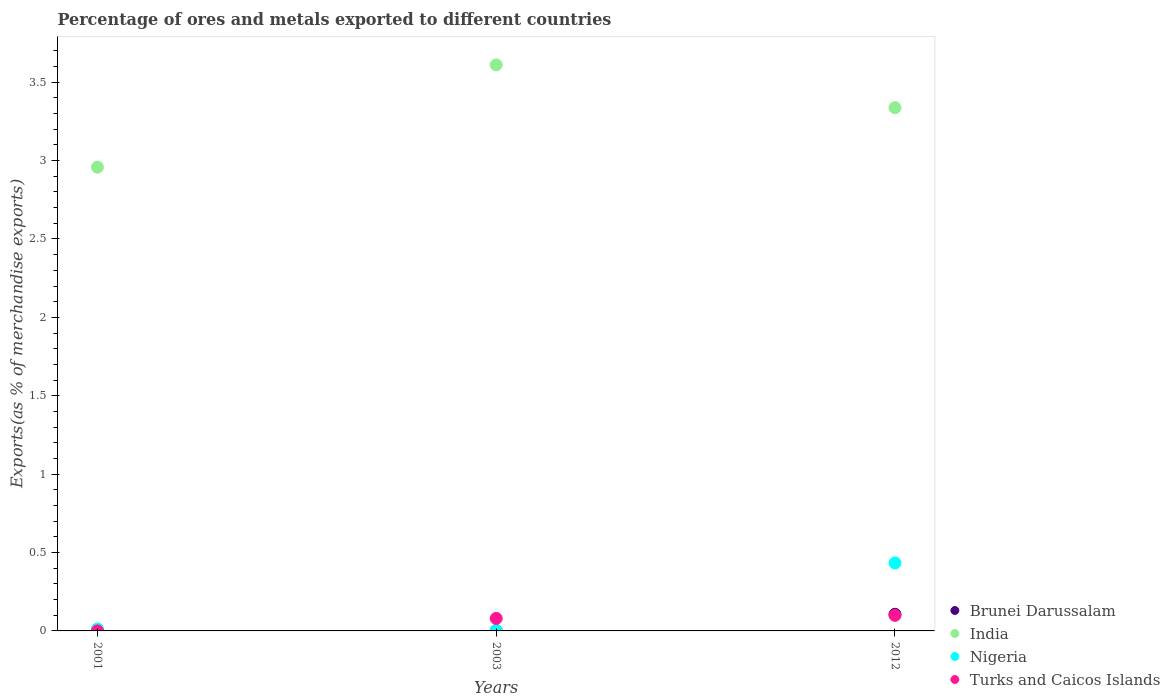How many different coloured dotlines are there?
Provide a succinct answer. 4. Is the number of dotlines equal to the number of legend labels?
Provide a short and direct response. Yes. What is the percentage of exports to different countries in Turks and Caicos Islands in 2003?
Ensure brevity in your answer.  0.08. Across all years, what is the maximum percentage of exports to different countries in Brunei Darussalam?
Make the answer very short. 0.11. Across all years, what is the minimum percentage of exports to different countries in India?
Provide a short and direct response. 2.96. In which year was the percentage of exports to different countries in India maximum?
Keep it short and to the point. 2003. In which year was the percentage of exports to different countries in India minimum?
Keep it short and to the point. 2001. What is the total percentage of exports to different countries in India in the graph?
Offer a terse response. 9.91. What is the difference between the percentage of exports to different countries in India in 2003 and that in 2012?
Give a very brief answer. 0.27. What is the difference between the percentage of exports to different countries in Turks and Caicos Islands in 2003 and the percentage of exports to different countries in Nigeria in 2001?
Offer a very short reply. 0.07. What is the average percentage of exports to different countries in Nigeria per year?
Provide a succinct answer. 0.15. In the year 2012, what is the difference between the percentage of exports to different countries in Brunei Darussalam and percentage of exports to different countries in Turks and Caicos Islands?
Make the answer very short. 0.01. In how many years, is the percentage of exports to different countries in Turks and Caicos Islands greater than 1.1 %?
Keep it short and to the point. 0. What is the ratio of the percentage of exports to different countries in Nigeria in 2003 to that in 2012?
Ensure brevity in your answer.  0.01. Is the percentage of exports to different countries in Nigeria in 2001 less than that in 2012?
Offer a very short reply. Yes. What is the difference between the highest and the second highest percentage of exports to different countries in Nigeria?
Give a very brief answer. 0.42. What is the difference between the highest and the lowest percentage of exports to different countries in Nigeria?
Offer a terse response. 0.43. Is the sum of the percentage of exports to different countries in Brunei Darussalam in 2003 and 2012 greater than the maximum percentage of exports to different countries in Nigeria across all years?
Provide a short and direct response. No. Does the percentage of exports to different countries in Brunei Darussalam monotonically increase over the years?
Your answer should be compact. No. Is the percentage of exports to different countries in Turks and Caicos Islands strictly greater than the percentage of exports to different countries in India over the years?
Your response must be concise. No. Is the percentage of exports to different countries in Nigeria strictly less than the percentage of exports to different countries in Turks and Caicos Islands over the years?
Offer a terse response. No. How many dotlines are there?
Provide a short and direct response. 4. What is the difference between two consecutive major ticks on the Y-axis?
Offer a terse response. 0.5. Does the graph contain grids?
Your answer should be compact. No. How many legend labels are there?
Keep it short and to the point. 4. How are the legend labels stacked?
Give a very brief answer. Vertical. What is the title of the graph?
Your answer should be compact. Percentage of ores and metals exported to different countries. What is the label or title of the Y-axis?
Keep it short and to the point. Exports(as % of merchandise exports). What is the Exports(as % of merchandise exports) of Brunei Darussalam in 2001?
Your answer should be very brief. 0. What is the Exports(as % of merchandise exports) of India in 2001?
Give a very brief answer. 2.96. What is the Exports(as % of merchandise exports) of Nigeria in 2001?
Give a very brief answer. 0.01. What is the Exports(as % of merchandise exports) of Turks and Caicos Islands in 2001?
Your response must be concise. 0. What is the Exports(as % of merchandise exports) in Brunei Darussalam in 2003?
Give a very brief answer. 0. What is the Exports(as % of merchandise exports) of India in 2003?
Your response must be concise. 3.61. What is the Exports(as % of merchandise exports) of Nigeria in 2003?
Provide a short and direct response. 0. What is the Exports(as % of merchandise exports) in Turks and Caicos Islands in 2003?
Your response must be concise. 0.08. What is the Exports(as % of merchandise exports) in Brunei Darussalam in 2012?
Offer a terse response. 0.11. What is the Exports(as % of merchandise exports) in India in 2012?
Your answer should be very brief. 3.34. What is the Exports(as % of merchandise exports) of Nigeria in 2012?
Offer a terse response. 0.43. What is the Exports(as % of merchandise exports) in Turks and Caicos Islands in 2012?
Ensure brevity in your answer.  0.1. Across all years, what is the maximum Exports(as % of merchandise exports) of Brunei Darussalam?
Offer a very short reply. 0.11. Across all years, what is the maximum Exports(as % of merchandise exports) of India?
Ensure brevity in your answer.  3.61. Across all years, what is the maximum Exports(as % of merchandise exports) in Nigeria?
Make the answer very short. 0.43. Across all years, what is the maximum Exports(as % of merchandise exports) in Turks and Caicos Islands?
Offer a very short reply. 0.1. Across all years, what is the minimum Exports(as % of merchandise exports) of Brunei Darussalam?
Ensure brevity in your answer.  0. Across all years, what is the minimum Exports(as % of merchandise exports) of India?
Give a very brief answer. 2.96. Across all years, what is the minimum Exports(as % of merchandise exports) of Nigeria?
Keep it short and to the point. 0. Across all years, what is the minimum Exports(as % of merchandise exports) in Turks and Caicos Islands?
Provide a succinct answer. 0. What is the total Exports(as % of merchandise exports) in Brunei Darussalam in the graph?
Make the answer very short. 0.11. What is the total Exports(as % of merchandise exports) of India in the graph?
Your answer should be compact. 9.91. What is the total Exports(as % of merchandise exports) of Nigeria in the graph?
Provide a short and direct response. 0.45. What is the total Exports(as % of merchandise exports) in Turks and Caicos Islands in the graph?
Give a very brief answer. 0.18. What is the difference between the Exports(as % of merchandise exports) of India in 2001 and that in 2003?
Your answer should be compact. -0.65. What is the difference between the Exports(as % of merchandise exports) of Nigeria in 2001 and that in 2003?
Give a very brief answer. 0.01. What is the difference between the Exports(as % of merchandise exports) of Turks and Caicos Islands in 2001 and that in 2003?
Give a very brief answer. -0.08. What is the difference between the Exports(as % of merchandise exports) of Brunei Darussalam in 2001 and that in 2012?
Your response must be concise. -0.1. What is the difference between the Exports(as % of merchandise exports) in India in 2001 and that in 2012?
Keep it short and to the point. -0.38. What is the difference between the Exports(as % of merchandise exports) in Nigeria in 2001 and that in 2012?
Make the answer very short. -0.42. What is the difference between the Exports(as % of merchandise exports) of Turks and Caicos Islands in 2001 and that in 2012?
Keep it short and to the point. -0.1. What is the difference between the Exports(as % of merchandise exports) of Brunei Darussalam in 2003 and that in 2012?
Provide a succinct answer. -0.11. What is the difference between the Exports(as % of merchandise exports) of India in 2003 and that in 2012?
Provide a succinct answer. 0.27. What is the difference between the Exports(as % of merchandise exports) of Nigeria in 2003 and that in 2012?
Give a very brief answer. -0.43. What is the difference between the Exports(as % of merchandise exports) of Turks and Caicos Islands in 2003 and that in 2012?
Ensure brevity in your answer.  -0.02. What is the difference between the Exports(as % of merchandise exports) in Brunei Darussalam in 2001 and the Exports(as % of merchandise exports) in India in 2003?
Your response must be concise. -3.61. What is the difference between the Exports(as % of merchandise exports) in Brunei Darussalam in 2001 and the Exports(as % of merchandise exports) in Nigeria in 2003?
Ensure brevity in your answer.  -0. What is the difference between the Exports(as % of merchandise exports) of Brunei Darussalam in 2001 and the Exports(as % of merchandise exports) of Turks and Caicos Islands in 2003?
Ensure brevity in your answer.  -0.08. What is the difference between the Exports(as % of merchandise exports) of India in 2001 and the Exports(as % of merchandise exports) of Nigeria in 2003?
Make the answer very short. 2.96. What is the difference between the Exports(as % of merchandise exports) of India in 2001 and the Exports(as % of merchandise exports) of Turks and Caicos Islands in 2003?
Ensure brevity in your answer.  2.88. What is the difference between the Exports(as % of merchandise exports) of Nigeria in 2001 and the Exports(as % of merchandise exports) of Turks and Caicos Islands in 2003?
Give a very brief answer. -0.07. What is the difference between the Exports(as % of merchandise exports) of Brunei Darussalam in 2001 and the Exports(as % of merchandise exports) of India in 2012?
Offer a very short reply. -3.34. What is the difference between the Exports(as % of merchandise exports) of Brunei Darussalam in 2001 and the Exports(as % of merchandise exports) of Nigeria in 2012?
Your response must be concise. -0.43. What is the difference between the Exports(as % of merchandise exports) of Brunei Darussalam in 2001 and the Exports(as % of merchandise exports) of Turks and Caicos Islands in 2012?
Your answer should be compact. -0.1. What is the difference between the Exports(as % of merchandise exports) of India in 2001 and the Exports(as % of merchandise exports) of Nigeria in 2012?
Give a very brief answer. 2.52. What is the difference between the Exports(as % of merchandise exports) of India in 2001 and the Exports(as % of merchandise exports) of Turks and Caicos Islands in 2012?
Make the answer very short. 2.86. What is the difference between the Exports(as % of merchandise exports) in Nigeria in 2001 and the Exports(as % of merchandise exports) in Turks and Caicos Islands in 2012?
Your answer should be compact. -0.09. What is the difference between the Exports(as % of merchandise exports) in Brunei Darussalam in 2003 and the Exports(as % of merchandise exports) in India in 2012?
Provide a succinct answer. -3.34. What is the difference between the Exports(as % of merchandise exports) in Brunei Darussalam in 2003 and the Exports(as % of merchandise exports) in Nigeria in 2012?
Offer a very short reply. -0.43. What is the difference between the Exports(as % of merchandise exports) in Brunei Darussalam in 2003 and the Exports(as % of merchandise exports) in Turks and Caicos Islands in 2012?
Give a very brief answer. -0.1. What is the difference between the Exports(as % of merchandise exports) in India in 2003 and the Exports(as % of merchandise exports) in Nigeria in 2012?
Your answer should be compact. 3.18. What is the difference between the Exports(as % of merchandise exports) of India in 2003 and the Exports(as % of merchandise exports) of Turks and Caicos Islands in 2012?
Give a very brief answer. 3.51. What is the difference between the Exports(as % of merchandise exports) in Nigeria in 2003 and the Exports(as % of merchandise exports) in Turks and Caicos Islands in 2012?
Keep it short and to the point. -0.1. What is the average Exports(as % of merchandise exports) in Brunei Darussalam per year?
Provide a short and direct response. 0.04. What is the average Exports(as % of merchandise exports) of India per year?
Your answer should be very brief. 3.3. What is the average Exports(as % of merchandise exports) of Nigeria per year?
Provide a succinct answer. 0.15. What is the average Exports(as % of merchandise exports) in Turks and Caicos Islands per year?
Provide a succinct answer. 0.06. In the year 2001, what is the difference between the Exports(as % of merchandise exports) in Brunei Darussalam and Exports(as % of merchandise exports) in India?
Make the answer very short. -2.96. In the year 2001, what is the difference between the Exports(as % of merchandise exports) in Brunei Darussalam and Exports(as % of merchandise exports) in Nigeria?
Make the answer very short. -0.01. In the year 2001, what is the difference between the Exports(as % of merchandise exports) of Brunei Darussalam and Exports(as % of merchandise exports) of Turks and Caicos Islands?
Offer a terse response. 0. In the year 2001, what is the difference between the Exports(as % of merchandise exports) in India and Exports(as % of merchandise exports) in Nigeria?
Keep it short and to the point. 2.95. In the year 2001, what is the difference between the Exports(as % of merchandise exports) of India and Exports(as % of merchandise exports) of Turks and Caicos Islands?
Make the answer very short. 2.96. In the year 2001, what is the difference between the Exports(as % of merchandise exports) in Nigeria and Exports(as % of merchandise exports) in Turks and Caicos Islands?
Keep it short and to the point. 0.01. In the year 2003, what is the difference between the Exports(as % of merchandise exports) in Brunei Darussalam and Exports(as % of merchandise exports) in India?
Provide a short and direct response. -3.61. In the year 2003, what is the difference between the Exports(as % of merchandise exports) in Brunei Darussalam and Exports(as % of merchandise exports) in Nigeria?
Provide a short and direct response. -0. In the year 2003, what is the difference between the Exports(as % of merchandise exports) in Brunei Darussalam and Exports(as % of merchandise exports) in Turks and Caicos Islands?
Offer a very short reply. -0.08. In the year 2003, what is the difference between the Exports(as % of merchandise exports) in India and Exports(as % of merchandise exports) in Nigeria?
Your response must be concise. 3.61. In the year 2003, what is the difference between the Exports(as % of merchandise exports) of India and Exports(as % of merchandise exports) of Turks and Caicos Islands?
Provide a succinct answer. 3.53. In the year 2003, what is the difference between the Exports(as % of merchandise exports) in Nigeria and Exports(as % of merchandise exports) in Turks and Caicos Islands?
Offer a very short reply. -0.08. In the year 2012, what is the difference between the Exports(as % of merchandise exports) in Brunei Darussalam and Exports(as % of merchandise exports) in India?
Ensure brevity in your answer.  -3.23. In the year 2012, what is the difference between the Exports(as % of merchandise exports) of Brunei Darussalam and Exports(as % of merchandise exports) of Nigeria?
Make the answer very short. -0.33. In the year 2012, what is the difference between the Exports(as % of merchandise exports) of Brunei Darussalam and Exports(as % of merchandise exports) of Turks and Caicos Islands?
Provide a short and direct response. 0.01. In the year 2012, what is the difference between the Exports(as % of merchandise exports) in India and Exports(as % of merchandise exports) in Nigeria?
Give a very brief answer. 2.9. In the year 2012, what is the difference between the Exports(as % of merchandise exports) of India and Exports(as % of merchandise exports) of Turks and Caicos Islands?
Ensure brevity in your answer.  3.24. In the year 2012, what is the difference between the Exports(as % of merchandise exports) of Nigeria and Exports(as % of merchandise exports) of Turks and Caicos Islands?
Give a very brief answer. 0.33. What is the ratio of the Exports(as % of merchandise exports) of Brunei Darussalam in 2001 to that in 2003?
Provide a short and direct response. 1.65. What is the ratio of the Exports(as % of merchandise exports) in India in 2001 to that in 2003?
Offer a very short reply. 0.82. What is the ratio of the Exports(as % of merchandise exports) of Nigeria in 2001 to that in 2003?
Your answer should be very brief. 4.49. What is the ratio of the Exports(as % of merchandise exports) in Turks and Caicos Islands in 2001 to that in 2003?
Give a very brief answer. 0. What is the ratio of the Exports(as % of merchandise exports) in Brunei Darussalam in 2001 to that in 2012?
Provide a short and direct response. 0.01. What is the ratio of the Exports(as % of merchandise exports) of India in 2001 to that in 2012?
Make the answer very short. 0.89. What is the ratio of the Exports(as % of merchandise exports) in Nigeria in 2001 to that in 2012?
Offer a terse response. 0.03. What is the ratio of the Exports(as % of merchandise exports) of Turks and Caicos Islands in 2001 to that in 2012?
Ensure brevity in your answer.  0. What is the ratio of the Exports(as % of merchandise exports) in Brunei Darussalam in 2003 to that in 2012?
Give a very brief answer. 0.01. What is the ratio of the Exports(as % of merchandise exports) of India in 2003 to that in 2012?
Make the answer very short. 1.08. What is the ratio of the Exports(as % of merchandise exports) of Nigeria in 2003 to that in 2012?
Your answer should be compact. 0.01. What is the ratio of the Exports(as % of merchandise exports) of Turks and Caicos Islands in 2003 to that in 2012?
Make the answer very short. 0.8. What is the difference between the highest and the second highest Exports(as % of merchandise exports) in Brunei Darussalam?
Make the answer very short. 0.1. What is the difference between the highest and the second highest Exports(as % of merchandise exports) in India?
Provide a short and direct response. 0.27. What is the difference between the highest and the second highest Exports(as % of merchandise exports) of Nigeria?
Your response must be concise. 0.42. What is the difference between the highest and the second highest Exports(as % of merchandise exports) of Turks and Caicos Islands?
Offer a very short reply. 0.02. What is the difference between the highest and the lowest Exports(as % of merchandise exports) in Brunei Darussalam?
Your response must be concise. 0.11. What is the difference between the highest and the lowest Exports(as % of merchandise exports) in India?
Make the answer very short. 0.65. What is the difference between the highest and the lowest Exports(as % of merchandise exports) of Nigeria?
Offer a terse response. 0.43. What is the difference between the highest and the lowest Exports(as % of merchandise exports) of Turks and Caicos Islands?
Keep it short and to the point. 0.1. 